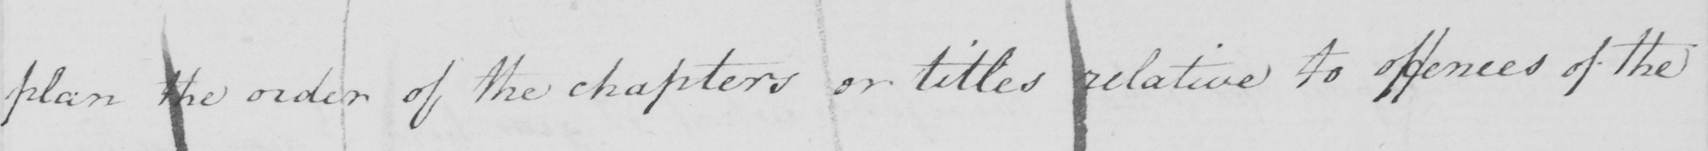Please transcribe the handwritten text in this image. plan the order of the chapters or titles relative to offences of the 